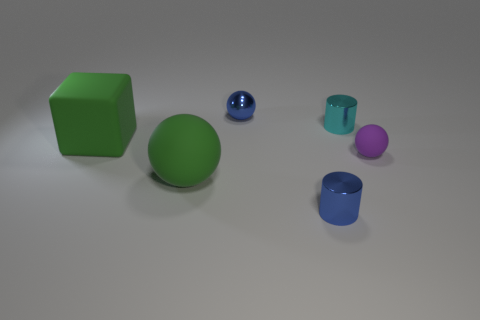Subtract all brown cylinders. Subtract all brown spheres. How many cylinders are left? 2 Add 1 big green rubber spheres. How many objects exist? 7 Subtract all cylinders. How many objects are left? 4 Subtract all big blocks. Subtract all shiny spheres. How many objects are left? 4 Add 6 big green matte objects. How many big green matte objects are left? 8 Add 6 cyan matte balls. How many cyan matte balls exist? 6 Subtract 0 cyan spheres. How many objects are left? 6 